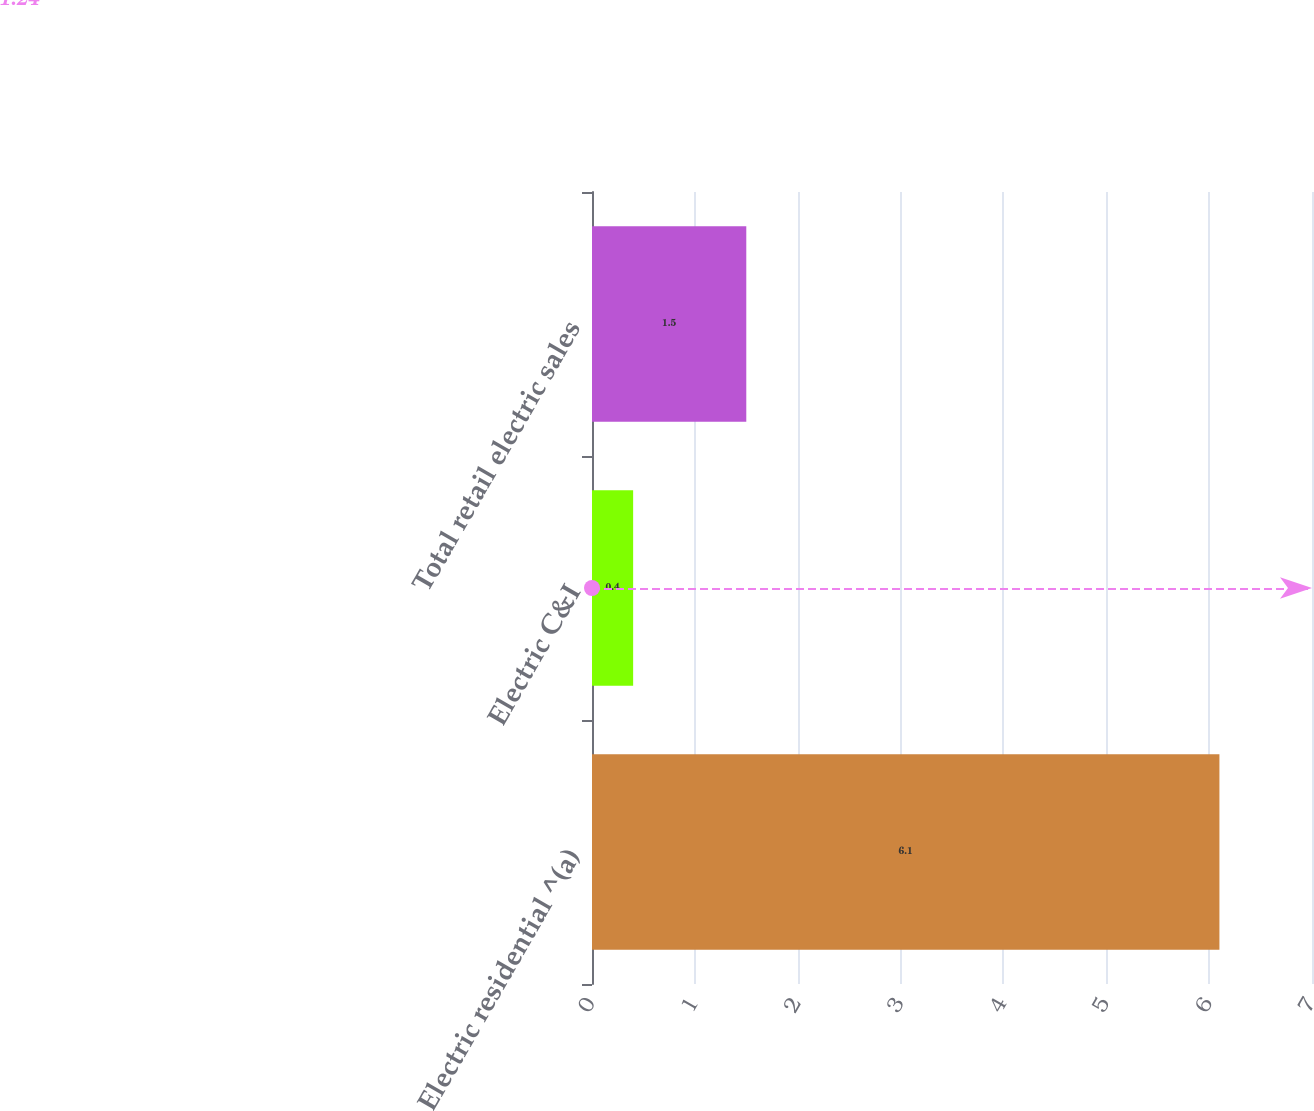<chart> <loc_0><loc_0><loc_500><loc_500><bar_chart><fcel>Electric residential ^(a)<fcel>Electric C&I<fcel>Total retail electric sales<nl><fcel>6.1<fcel>0.4<fcel>1.5<nl></chart> 